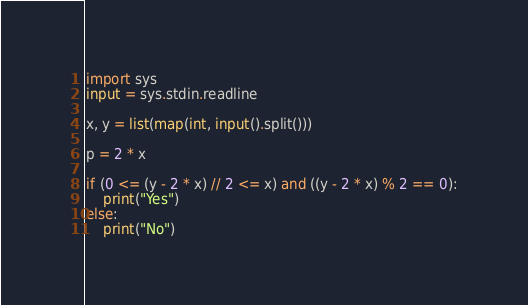<code> <loc_0><loc_0><loc_500><loc_500><_Python_>import sys
input = sys.stdin.readline

x, y = list(map(int, input().split()))

p = 2 * x

if (0 <= (y - 2 * x) // 2 <= x) and ((y - 2 * x) % 2 == 0):
    print("Yes")
else:
    print("No")</code> 